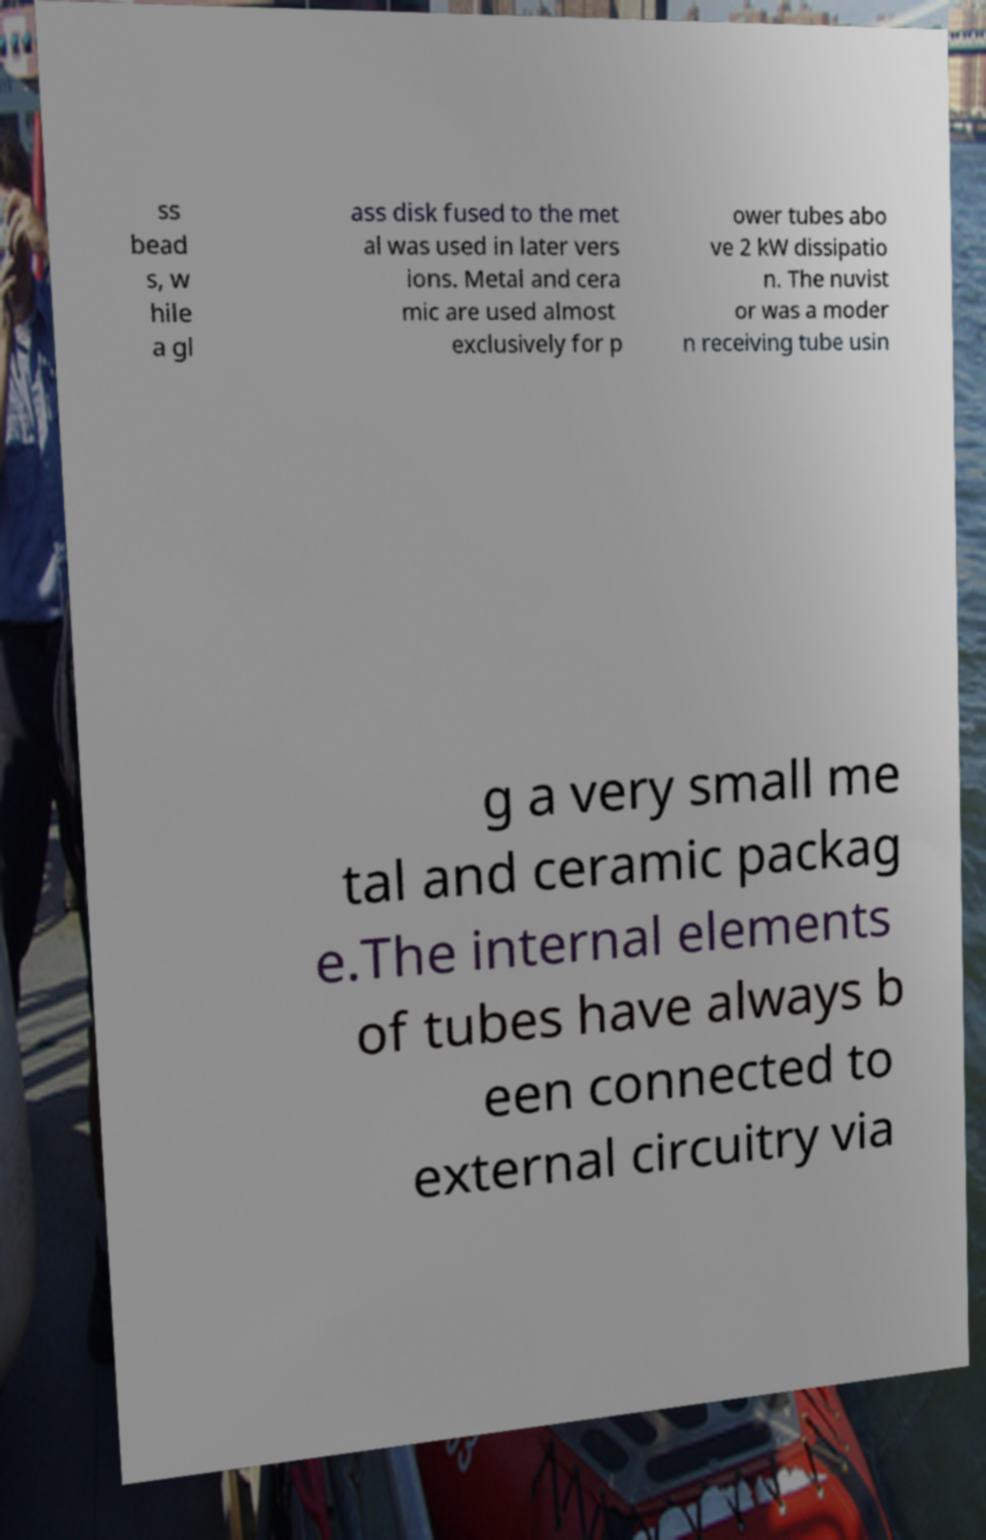Please identify and transcribe the text found in this image. ss bead s, w hile a gl ass disk fused to the met al was used in later vers ions. Metal and cera mic are used almost exclusively for p ower tubes abo ve 2 kW dissipatio n. The nuvist or was a moder n receiving tube usin g a very small me tal and ceramic packag e.The internal elements of tubes have always b een connected to external circuitry via 